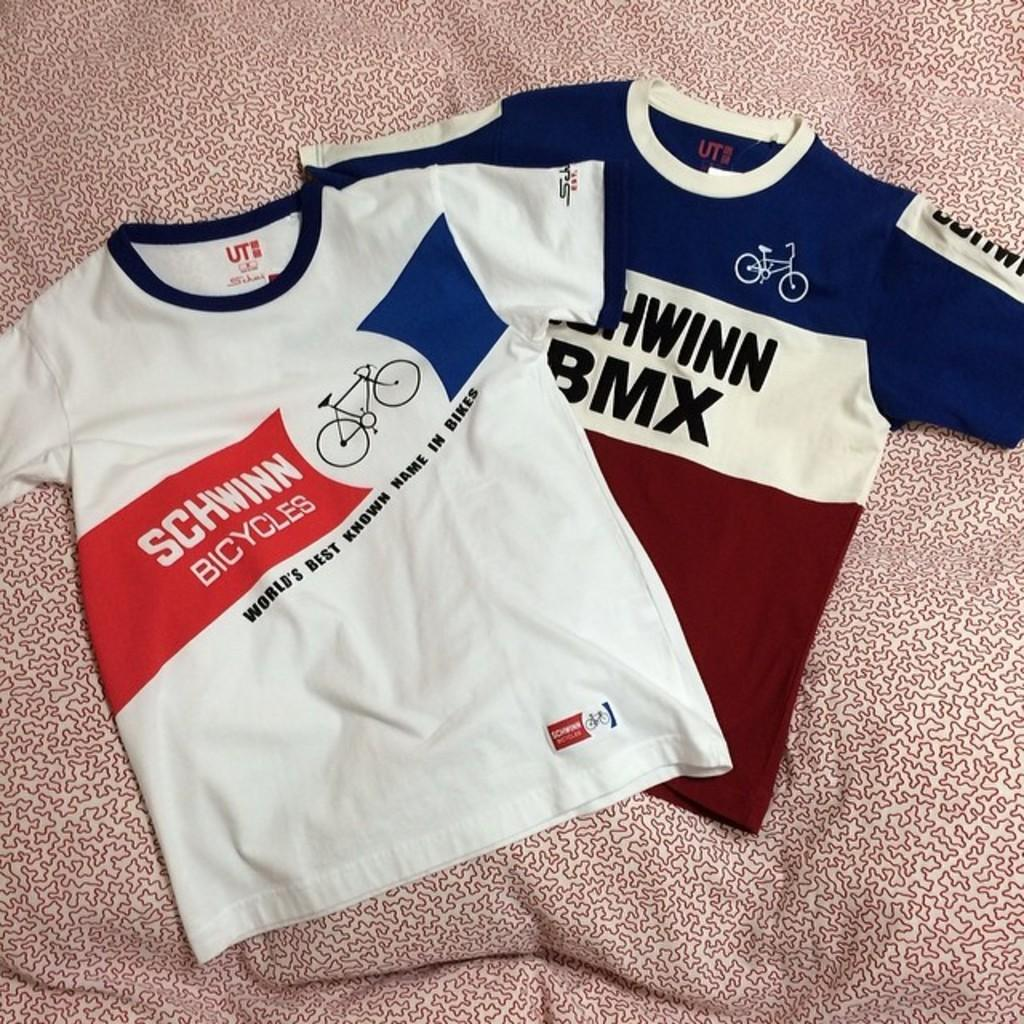Provide a one-sentence caption for the provided image. Two Schiwinn Bicycles shirts lying on a bed spread with one shirt being white with blue trim and the other shirt blue,white and red striped. 